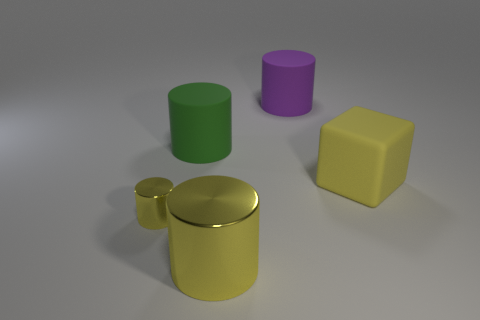How many things have the same color as the cube?
Give a very brief answer. 2. What number of other objects are there of the same shape as the big purple rubber thing?
Provide a short and direct response. 3. Is the shape of the big shiny object the same as the green object that is behind the tiny yellow metallic cylinder?
Your response must be concise. Yes. Is there anything else that is the same material as the large green cylinder?
Ensure brevity in your answer.  Yes. There is a small yellow thing that is the same shape as the large green matte thing; what is its material?
Provide a short and direct response. Metal. What number of large things are blue metallic objects or blocks?
Offer a very short reply. 1. Is the number of tiny cylinders on the right side of the big metal cylinder less than the number of large cubes that are on the right side of the green rubber cylinder?
Offer a terse response. Yes. What number of things are either large green things or tiny blue cylinders?
Provide a succinct answer. 1. How many big purple rubber cylinders are behind the small metallic object?
Provide a short and direct response. 1. Do the small thing and the rubber cube have the same color?
Offer a terse response. Yes. 